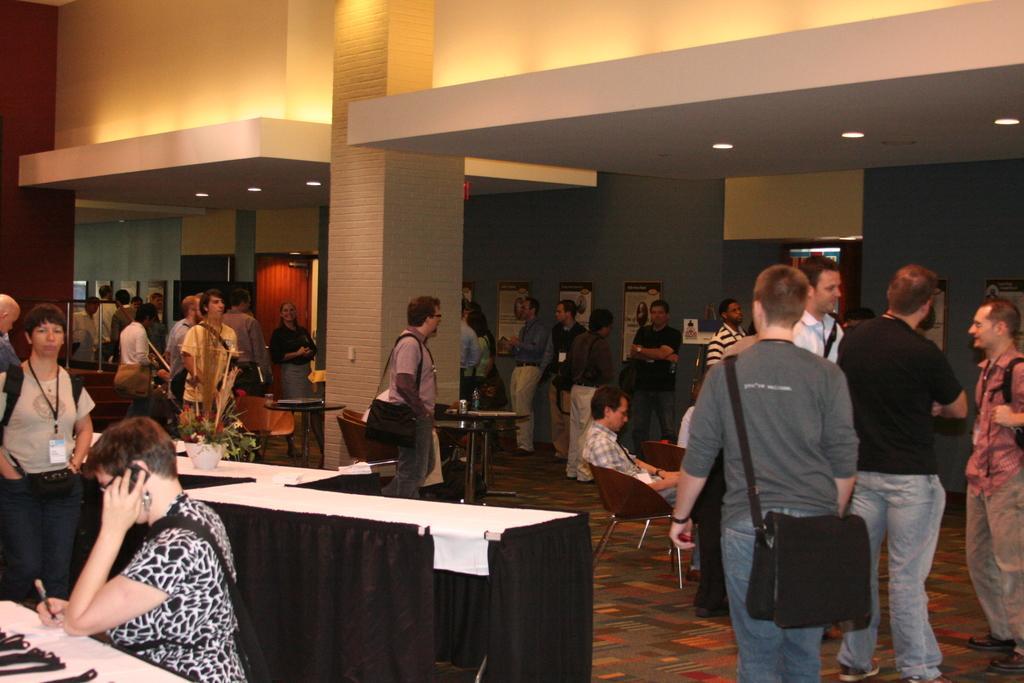In one or two sentences, can you explain what this image depicts? It is a meeting room a lot of people standing and talking with each other and some of them are sitting,many of them of wearing the bags ,in the background there is a grey color wall and some wall posters stick to it. 